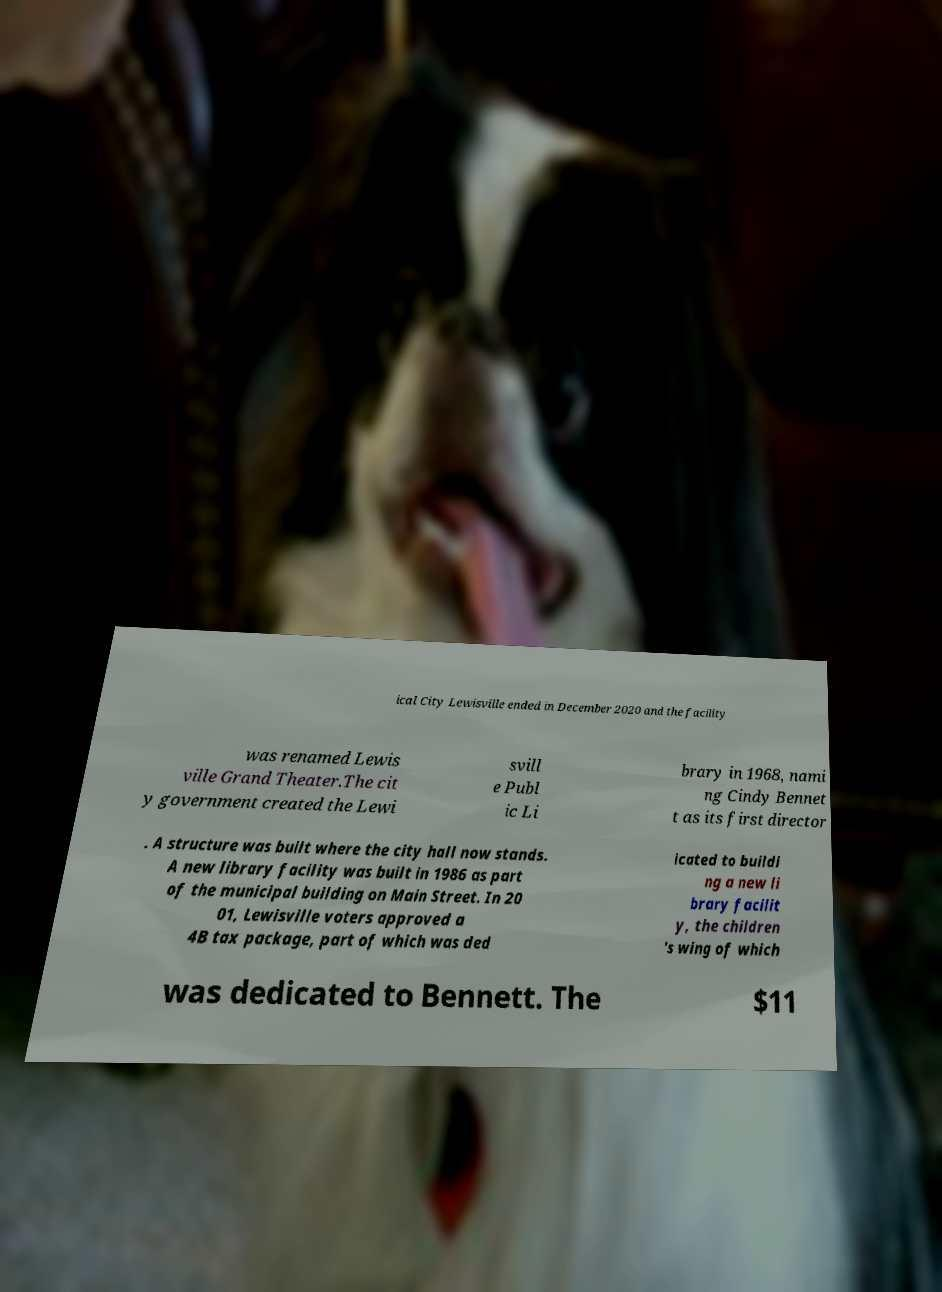Please identify and transcribe the text found in this image. ical City Lewisville ended in December 2020 and the facility was renamed Lewis ville Grand Theater.The cit y government created the Lewi svill e Publ ic Li brary in 1968, nami ng Cindy Bennet t as its first director . A structure was built where the city hall now stands. A new library facility was built in 1986 as part of the municipal building on Main Street. In 20 01, Lewisville voters approved a 4B tax package, part of which was ded icated to buildi ng a new li brary facilit y, the children 's wing of which was dedicated to Bennett. The $11 